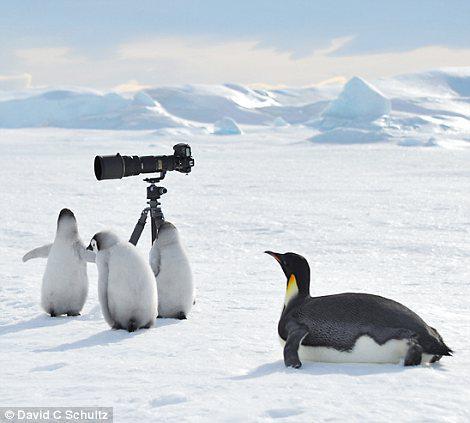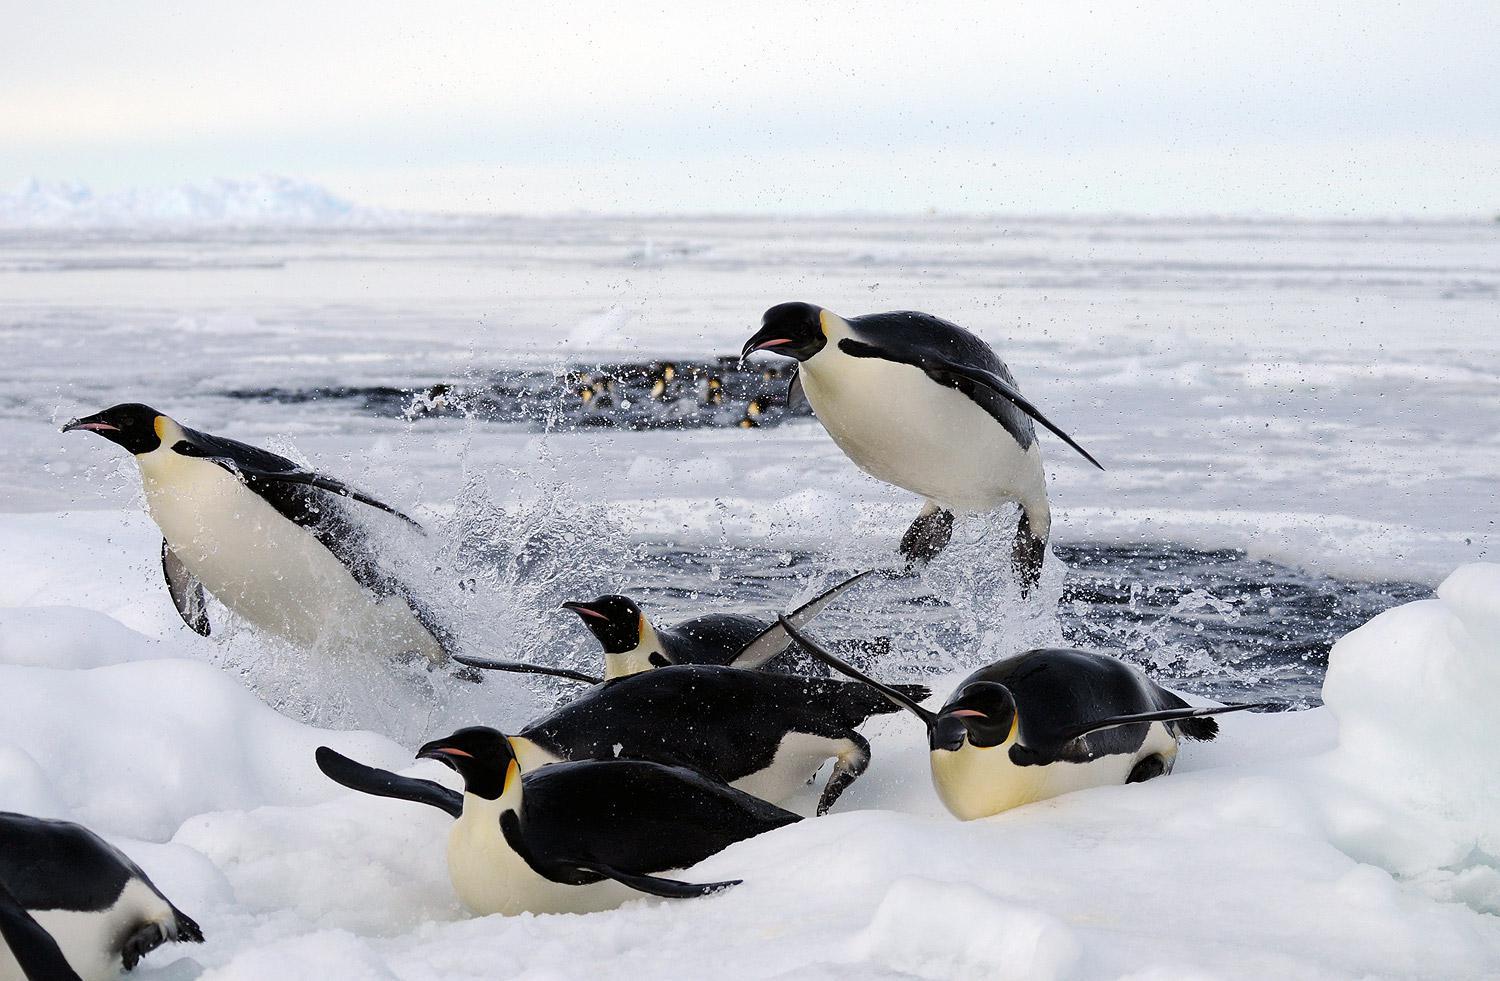The first image is the image on the left, the second image is the image on the right. For the images displayed, is the sentence "In one image of each pait a baby penguin has its mouth wide open." factually correct? Answer yes or no. No. The first image is the image on the left, the second image is the image on the right. For the images shown, is this caption "A baby penguin is standing near its mother with its mouth open." true? Answer yes or no. No. 